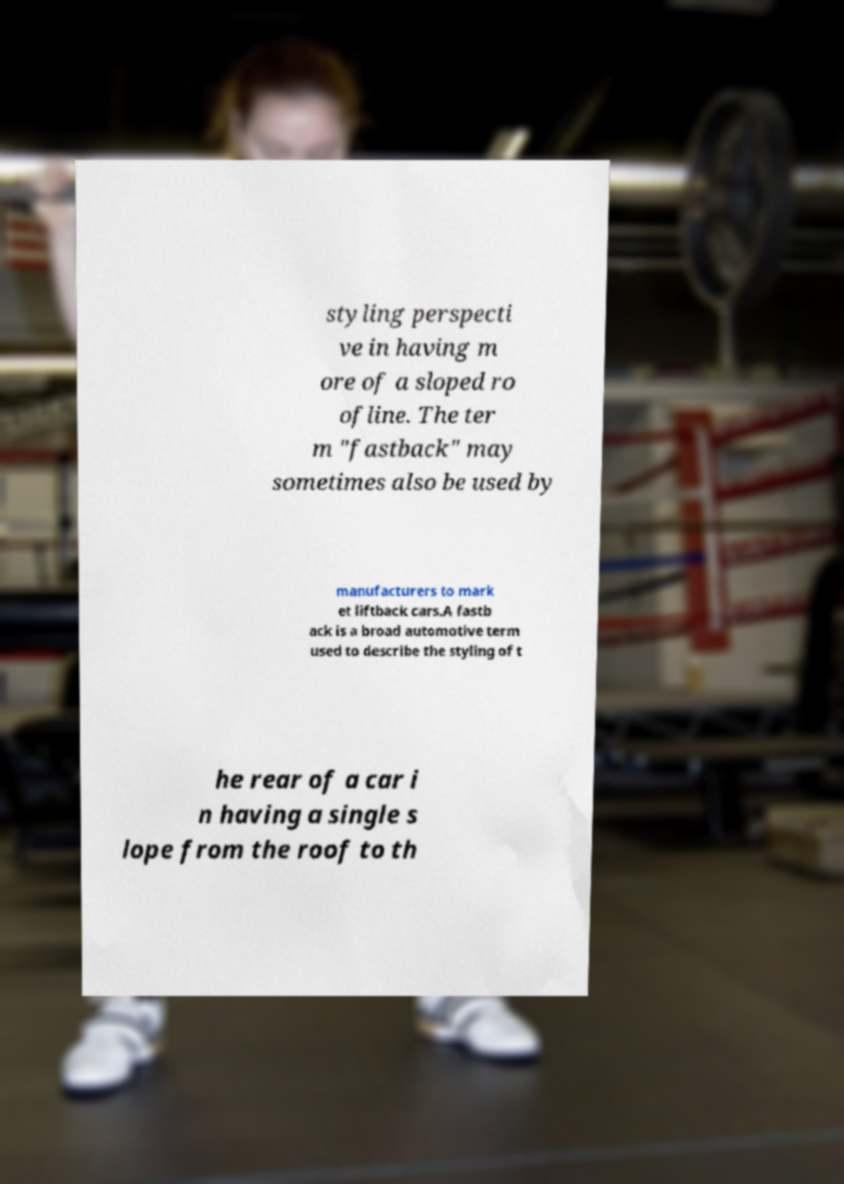For documentation purposes, I need the text within this image transcribed. Could you provide that? styling perspecti ve in having m ore of a sloped ro ofline. The ter m "fastback" may sometimes also be used by manufacturers to mark et liftback cars.A fastb ack is a broad automotive term used to describe the styling of t he rear of a car i n having a single s lope from the roof to th 